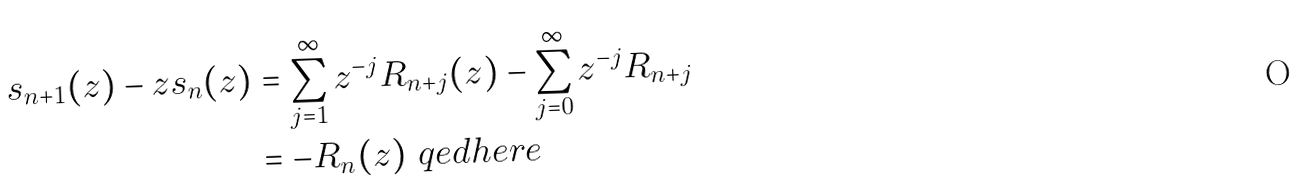Convert formula to latex. <formula><loc_0><loc_0><loc_500><loc_500>s _ { n + 1 } ( z ) - z s _ { n } ( z ) & = \sum _ { j = 1 } ^ { \infty } z ^ { - j } R _ { n + j } ( z ) - \sum _ { j = 0 } ^ { \infty } z ^ { - j } R _ { n + j } \\ & = - R _ { n } ( z ) \ q e d h e r e</formula> 